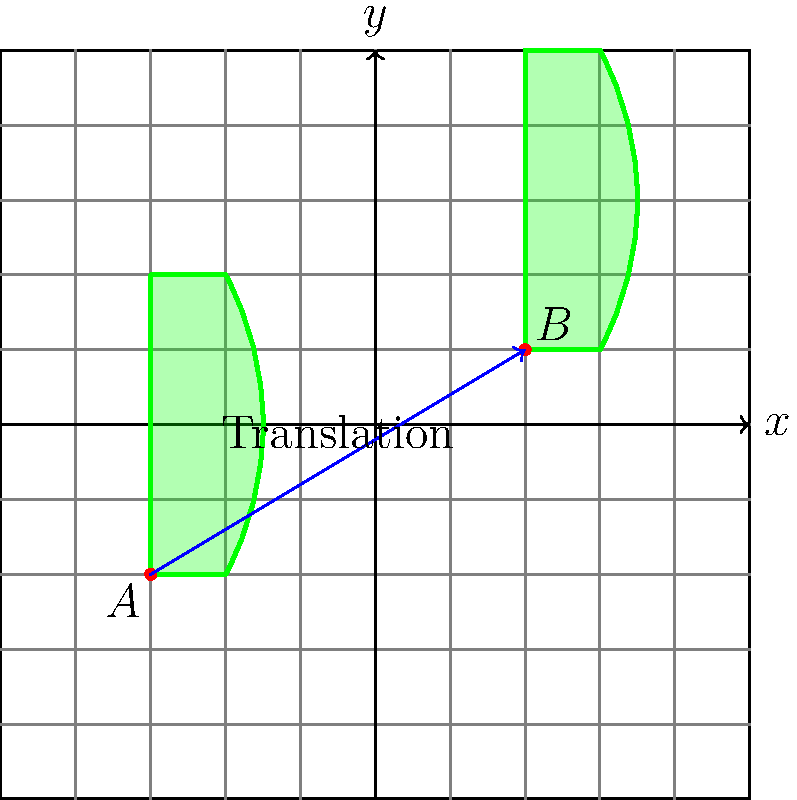A jar of pickles is represented by the green shape in the coordinate plane. The jar is translated from point $A$ to point $B$. What is the translation vector that describes this movement? To find the translation vector, we need to follow these steps:

1. Identify the coordinates of points $A$ and $B$:
   Point $A$ is at $(-3, -2)$
   Point $B$ is at $(2, 1)$

2. Calculate the difference between the $x$-coordinates:
   $x_B - x_A = 2 - (-3) = 2 + 3 = 5$

3. Calculate the difference between the $y$-coordinates:
   $y_B - y_A = 1 - (-2) = 1 + 2 = 3$

4. Express the translation vector as an ordered pair:
   Translation vector = $(5, 3)$

This vector represents the movement of the pickle jar from its initial position to its final position. It indicates that the jar has moved 5 units to the right and 3 units up.
Answer: $(5, 3)$ 